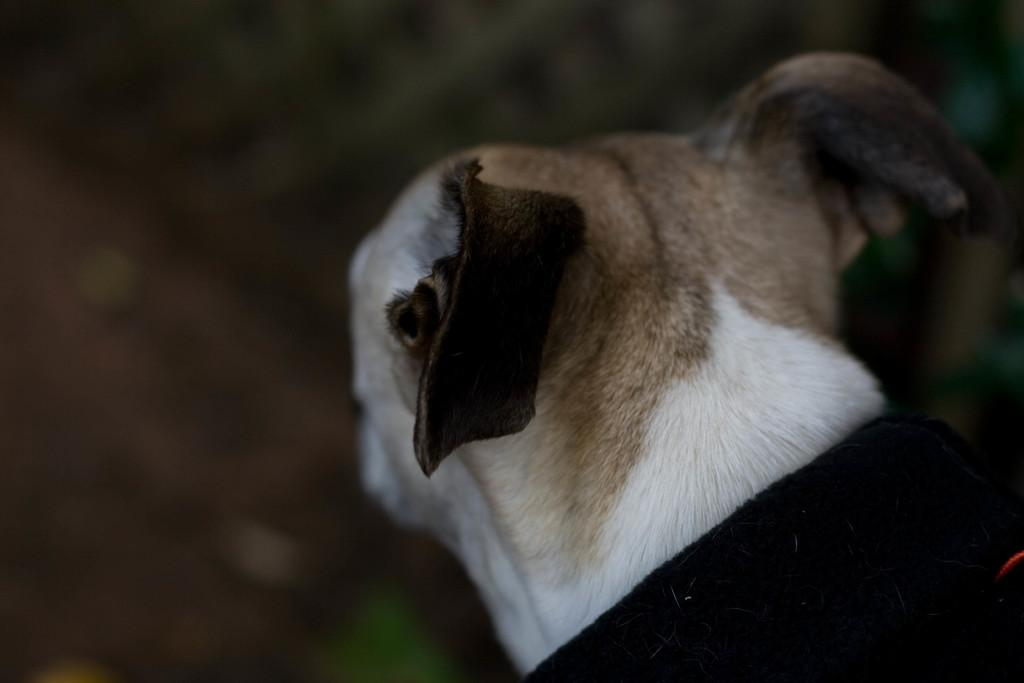What type of animal is in the image? There is a dog in the image. Where is the dog located in the image? The dog is on the right side of the image. Can you describe the background of the image? The background of the image is blurry. What is the level of wealth depicted in the image? There is no indication of wealth in the image, as it features a dog on the right side with a blurry background. 